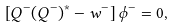Convert formula to latex. <formula><loc_0><loc_0><loc_500><loc_500>\left [ Q ^ { - } ( Q ^ { - } ) ^ { * } - w ^ { - } \right ] \phi ^ { - } = 0 ,</formula> 